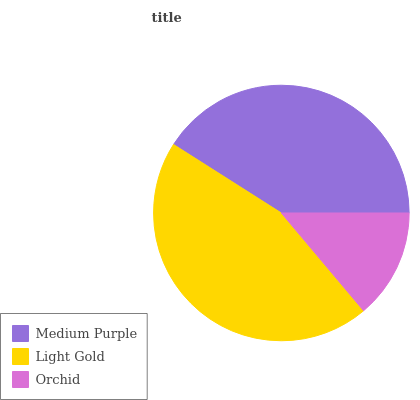Is Orchid the minimum?
Answer yes or no. Yes. Is Light Gold the maximum?
Answer yes or no. Yes. Is Light Gold the minimum?
Answer yes or no. No. Is Orchid the maximum?
Answer yes or no. No. Is Light Gold greater than Orchid?
Answer yes or no. Yes. Is Orchid less than Light Gold?
Answer yes or no. Yes. Is Orchid greater than Light Gold?
Answer yes or no. No. Is Light Gold less than Orchid?
Answer yes or no. No. Is Medium Purple the high median?
Answer yes or no. Yes. Is Medium Purple the low median?
Answer yes or no. Yes. Is Orchid the high median?
Answer yes or no. No. Is Orchid the low median?
Answer yes or no. No. 